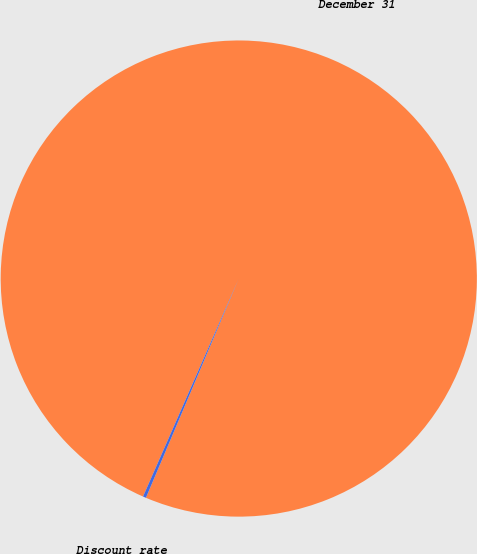Convert chart. <chart><loc_0><loc_0><loc_500><loc_500><pie_chart><fcel>December 31<fcel>Discount rate<nl><fcel>99.79%<fcel>0.21%<nl></chart> 